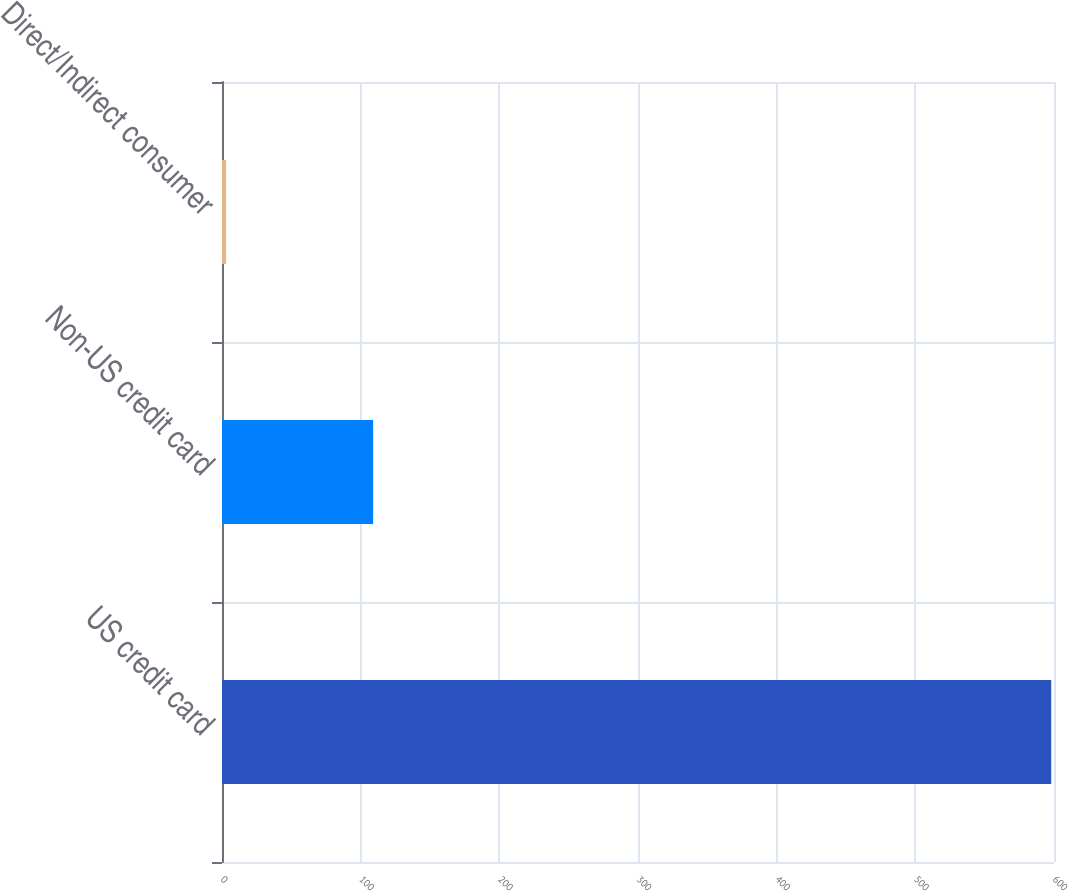Convert chart to OTSL. <chart><loc_0><loc_0><loc_500><loc_500><bar_chart><fcel>US credit card<fcel>Non-US credit card<fcel>Direct/Indirect consumer<nl><fcel>598<fcel>109<fcel>3<nl></chart> 